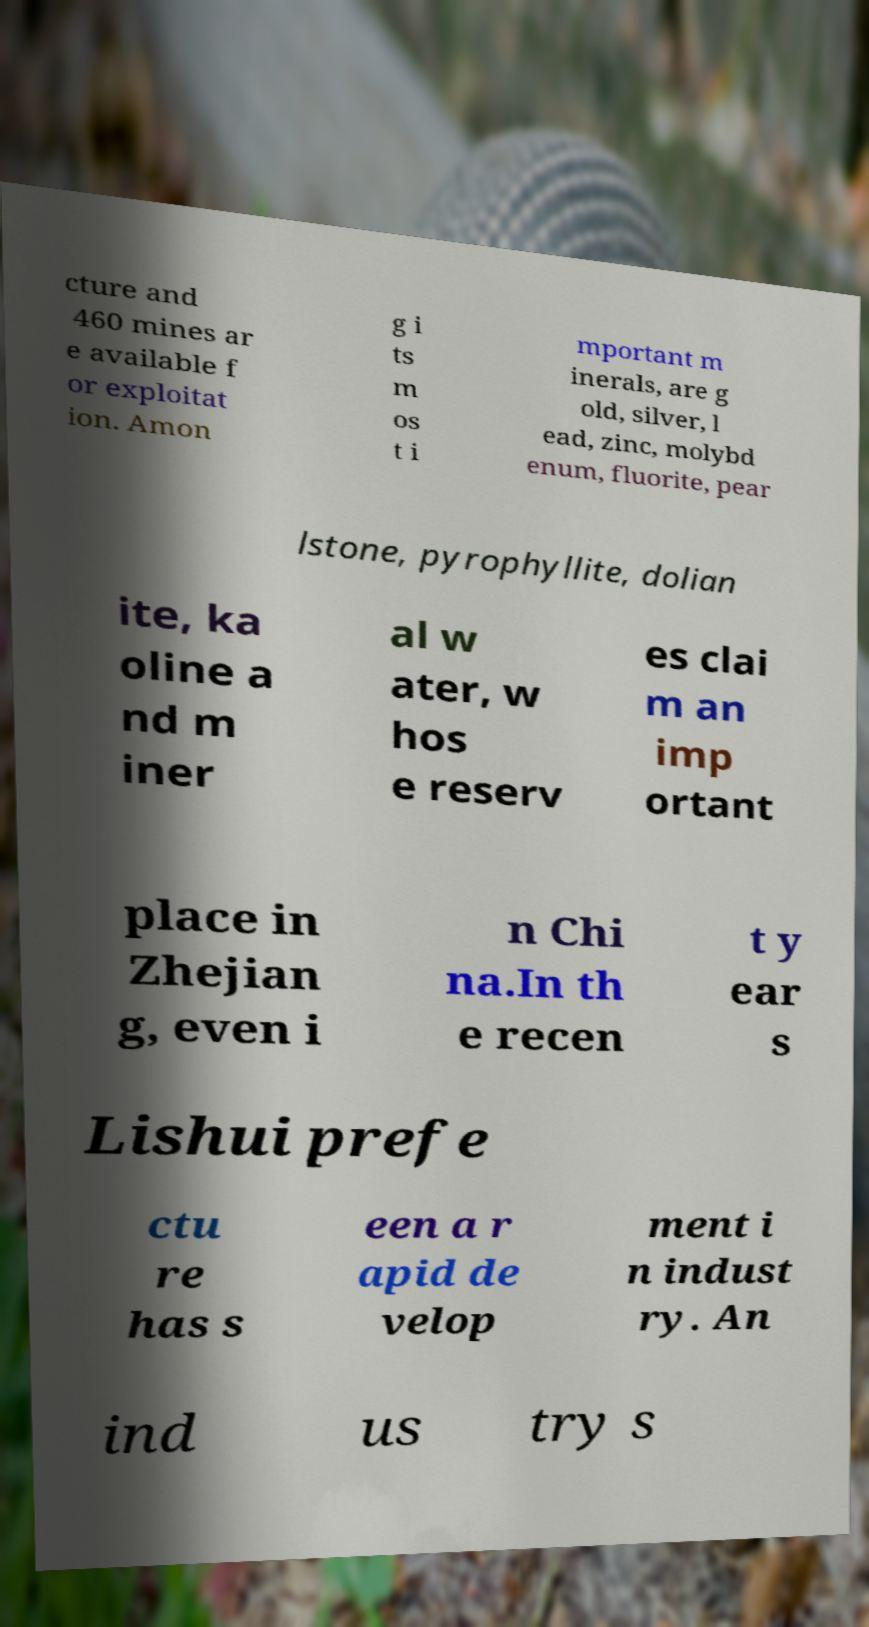What messages or text are displayed in this image? I need them in a readable, typed format. cture and 460 mines ar e available f or exploitat ion. Amon g i ts m os t i mportant m inerals, are g old, silver, l ead, zinc, molybd enum, fluorite, pear lstone, pyrophyllite, dolian ite, ka oline a nd m iner al w ater, w hos e reserv es clai m an imp ortant place in Zhejian g, even i n Chi na.In th e recen t y ear s Lishui prefe ctu re has s een a r apid de velop ment i n indust ry. An ind us try s 